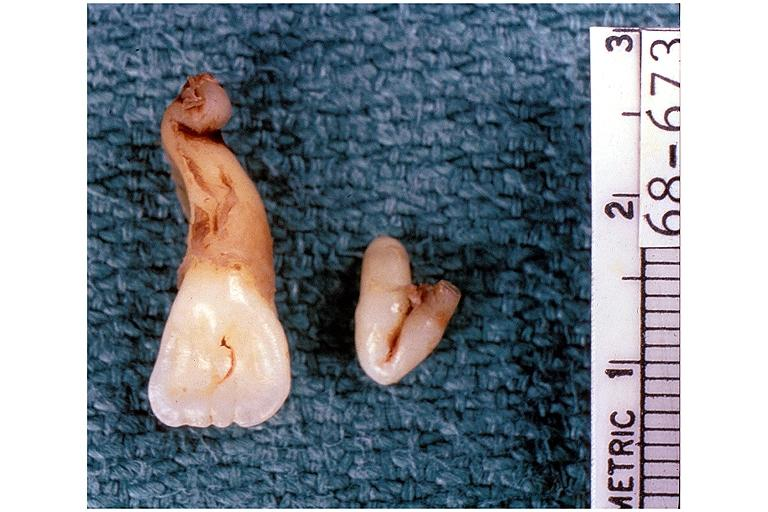where is this?
Answer the question using a single word or phrase. Oral 